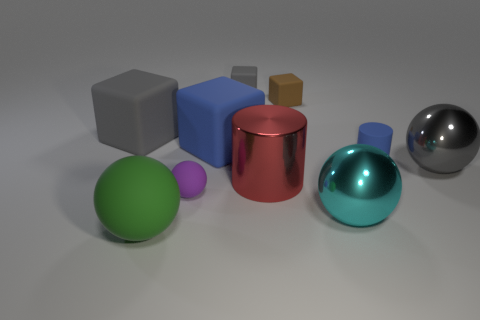How many shiny objects are large yellow cylinders or big blue blocks?
Your answer should be very brief. 0. What number of blue things are on the right side of the gray rubber thing that is in front of the gray matte block that is behind the tiny brown rubber block?
Provide a short and direct response. 2. There is a gray thing to the right of the small rubber cylinder; does it have the same size as the cylinder right of the red shiny cylinder?
Make the answer very short. No. What material is the small purple object that is the same shape as the cyan object?
Offer a very short reply. Rubber. How many large objects are either cylinders or cyan shiny spheres?
Provide a short and direct response. 2. What is the material of the big gray cube?
Provide a short and direct response. Rubber. The block that is to the left of the tiny gray matte thing and on the right side of the tiny purple thing is made of what material?
Your answer should be compact. Rubber. Does the matte cylinder have the same color as the big cube on the right side of the big green thing?
Give a very brief answer. Yes. What material is the gray block that is the same size as the green matte thing?
Provide a short and direct response. Rubber. Are there any brown blocks made of the same material as the big gray cube?
Your response must be concise. Yes. 